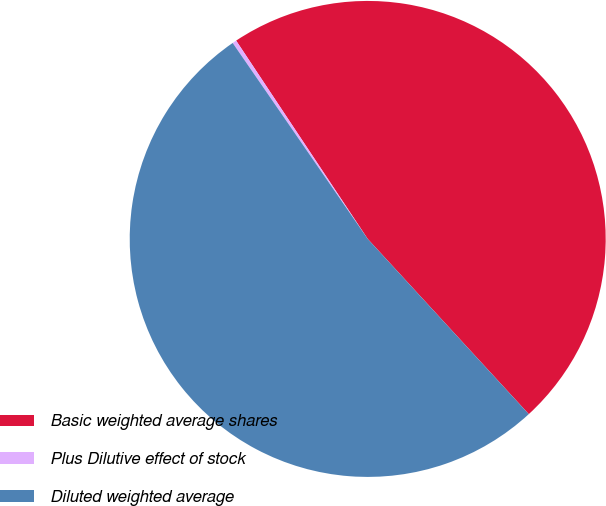Convert chart. <chart><loc_0><loc_0><loc_500><loc_500><pie_chart><fcel>Basic weighted average shares<fcel>Plus Dilutive effect of stock<fcel>Diluted weighted average<nl><fcel>47.49%<fcel>0.28%<fcel>52.23%<nl></chart> 